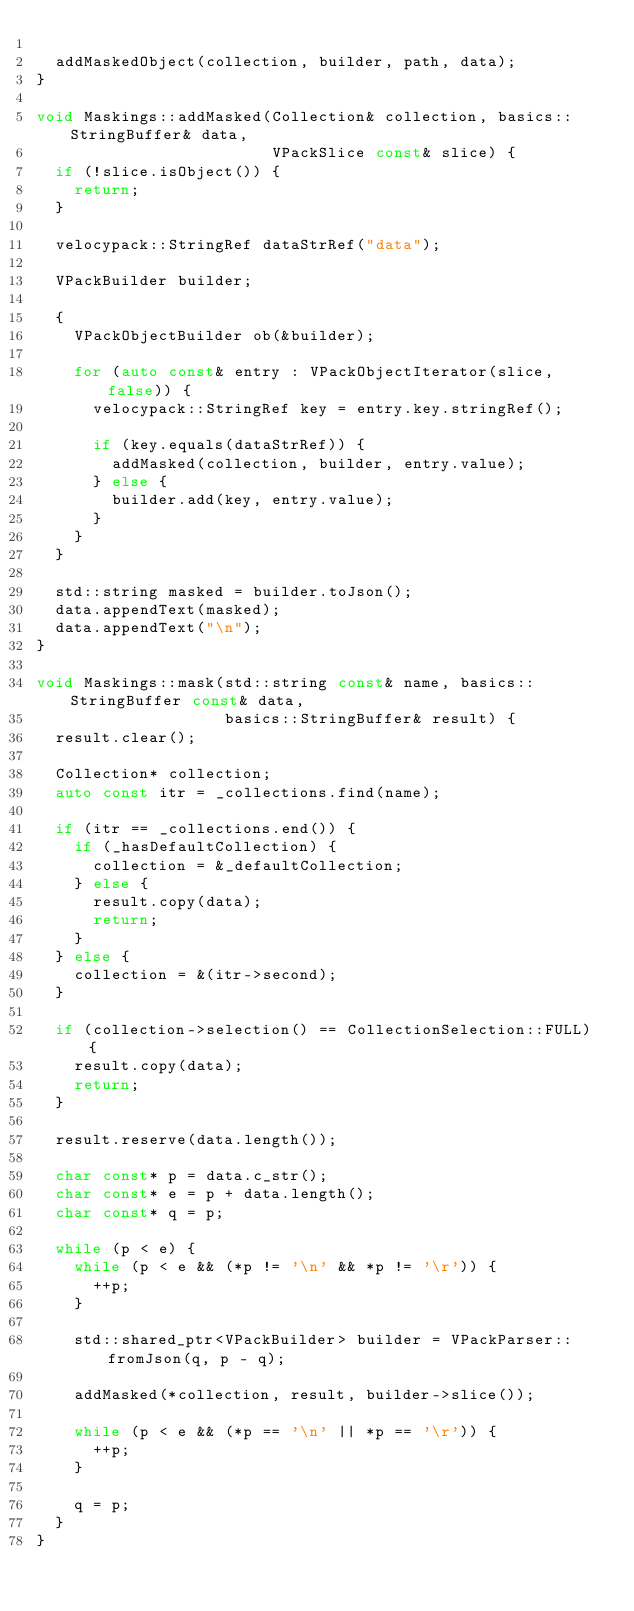Convert code to text. <code><loc_0><loc_0><loc_500><loc_500><_C++_>
  addMaskedObject(collection, builder, path, data);
}

void Maskings::addMasked(Collection& collection, basics::StringBuffer& data,
                         VPackSlice const& slice) {
  if (!slice.isObject()) {
    return;
  }

  velocypack::StringRef dataStrRef("data");

  VPackBuilder builder;

  {
    VPackObjectBuilder ob(&builder);

    for (auto const& entry : VPackObjectIterator(slice, false)) {
      velocypack::StringRef key = entry.key.stringRef();

      if (key.equals(dataStrRef)) {
        addMasked(collection, builder, entry.value);
      } else {
        builder.add(key, entry.value);
      }
    }
  }

  std::string masked = builder.toJson();
  data.appendText(masked);
  data.appendText("\n");
}

void Maskings::mask(std::string const& name, basics::StringBuffer const& data,
                    basics::StringBuffer& result) {
  result.clear();

  Collection* collection;
  auto const itr = _collections.find(name);

  if (itr == _collections.end()) {
    if (_hasDefaultCollection) {
      collection = &_defaultCollection;
    } else {
      result.copy(data);
      return;
    }
  } else {
    collection = &(itr->second);
  }

  if (collection->selection() == CollectionSelection::FULL) {
    result.copy(data);
    return;
  }

  result.reserve(data.length());

  char const* p = data.c_str();
  char const* e = p + data.length();
  char const* q = p;

  while (p < e) {
    while (p < e && (*p != '\n' && *p != '\r')) {
      ++p;
    }

    std::shared_ptr<VPackBuilder> builder = VPackParser::fromJson(q, p - q);

    addMasked(*collection, result, builder->slice());

    while (p < e && (*p == '\n' || *p == '\r')) {
      ++p;
    }

    q = p;
  }
}
</code> 